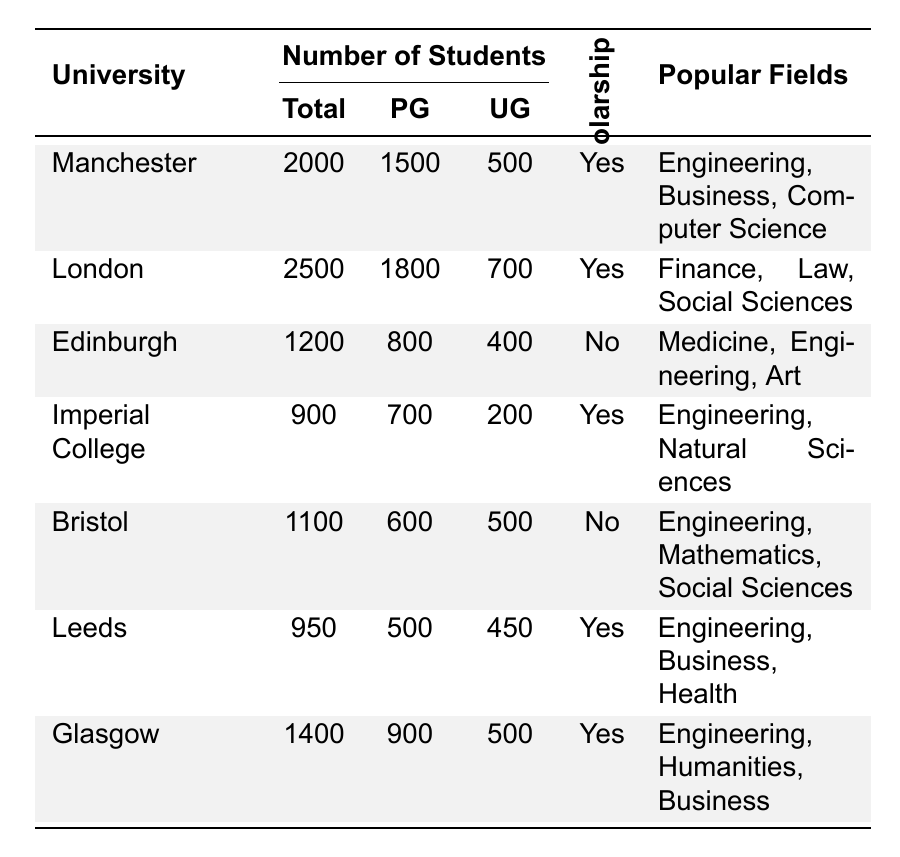What is the total number of Indian students at the University of London? The table shows that the University of London has a total of 2500 Indian students.
Answer: 2500 Which university has the highest number of postgraduate Indian students? The University of London has the highest number of postgraduate students, with a total of 1800.
Answer: University of London How many Indian undergraduate students study at the University of Manchester? According to the table, the University of Manchester has 500 undergraduate Indian students.
Answer: 500 Is there a scholarship available for Indian students at the University of Edinburgh? The table indicates that there is no scholarship available for Indian students at the University of Edinburgh.
Answer: No Which university has the lowest total number of Indian students? The University of Imperial College London has the lowest total with 900 Indian students.
Answer: Imperial College London What is the combined total of postgraduate and undergraduate Indian students at the University of Glasgow? The total of postgraduate students at the University of Glasgow is 900 and undergraduate students is 500, so the combined total is 900 + 500 = 1400.
Answer: 1400 How many universities offer scholarships for Indian students? According to the table, five universities offer scholarships for Indian students (Manchester, London, Imperial College, Leeds, and Glasgow).
Answer: 5 What are the popular fields of study for Indian students at the University of Bristol? The popular fields for Indian students at the University of Bristol are Engineering, Mathematics, and Social Sciences.
Answer: Engineering, Mathematics, Social Sciences What percentage of Indian students at the University of Leeds are postgraduate students? The University of Leeds has 950 total students and 500 of them are postgraduate. Therefore, the percentage is (500/950) * 100 = 52.63%.
Answer: 52.63% Compare the total number of Indian students at the University of Manchester and the University of Edinburgh. Which one has more? The University of Manchester has 2000 Indian students and the University of Edinburgh has 1200. Since 2000 is greater than 1200, the University of Manchester has more Indian students.
Answer: University of Manchester 